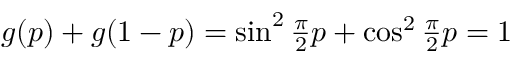<formula> <loc_0><loc_0><loc_500><loc_500>\begin{array} { r } { g ( p ) + g ( 1 - p ) = \sin ^ { 2 } \frac { \pi } { 2 } p + \cos ^ { 2 } \frac { \pi } { 2 } p = 1 } \end{array}</formula> 